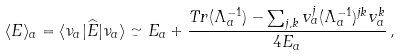Convert formula to latex. <formula><loc_0><loc_0><loc_500><loc_500>\langle E \rangle _ { a } = \langle \nu _ { a } | \widehat { E } | \nu _ { a } \rangle \simeq E _ { a } + \frac { T r ( \Lambda _ { a } ^ { - 1 } ) - \sum _ { j , k } v _ { a } ^ { j } ( \Lambda _ { a } ^ { - 1 } ) ^ { j k } v _ { a } ^ { k } } { 4 E _ { a } } \, ,</formula> 